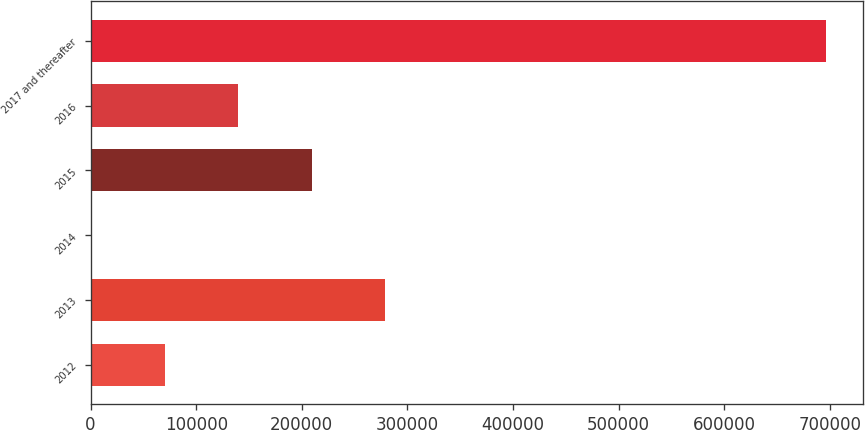Convert chart to OTSL. <chart><loc_0><loc_0><loc_500><loc_500><bar_chart><fcel>2012<fcel>2013<fcel>2014<fcel>2015<fcel>2016<fcel>2017 and thereafter<nl><fcel>69998.7<fcel>278885<fcel>370<fcel>209256<fcel>139627<fcel>696657<nl></chart> 